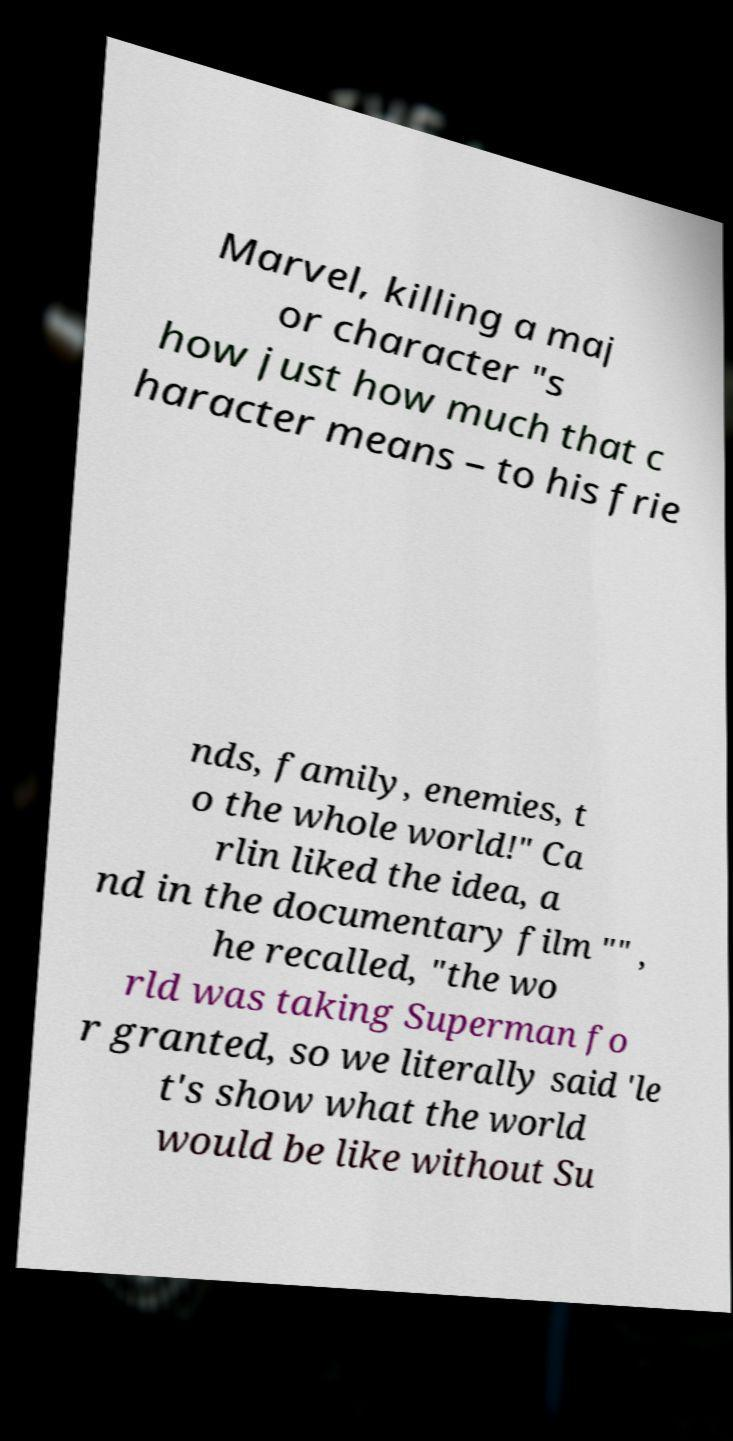Could you assist in decoding the text presented in this image and type it out clearly? Marvel, killing a maj or character "s how just how much that c haracter means – to his frie nds, family, enemies, t o the whole world!" Ca rlin liked the idea, a nd in the documentary film "" , he recalled, "the wo rld was taking Superman fo r granted, so we literally said 'le t's show what the world would be like without Su 